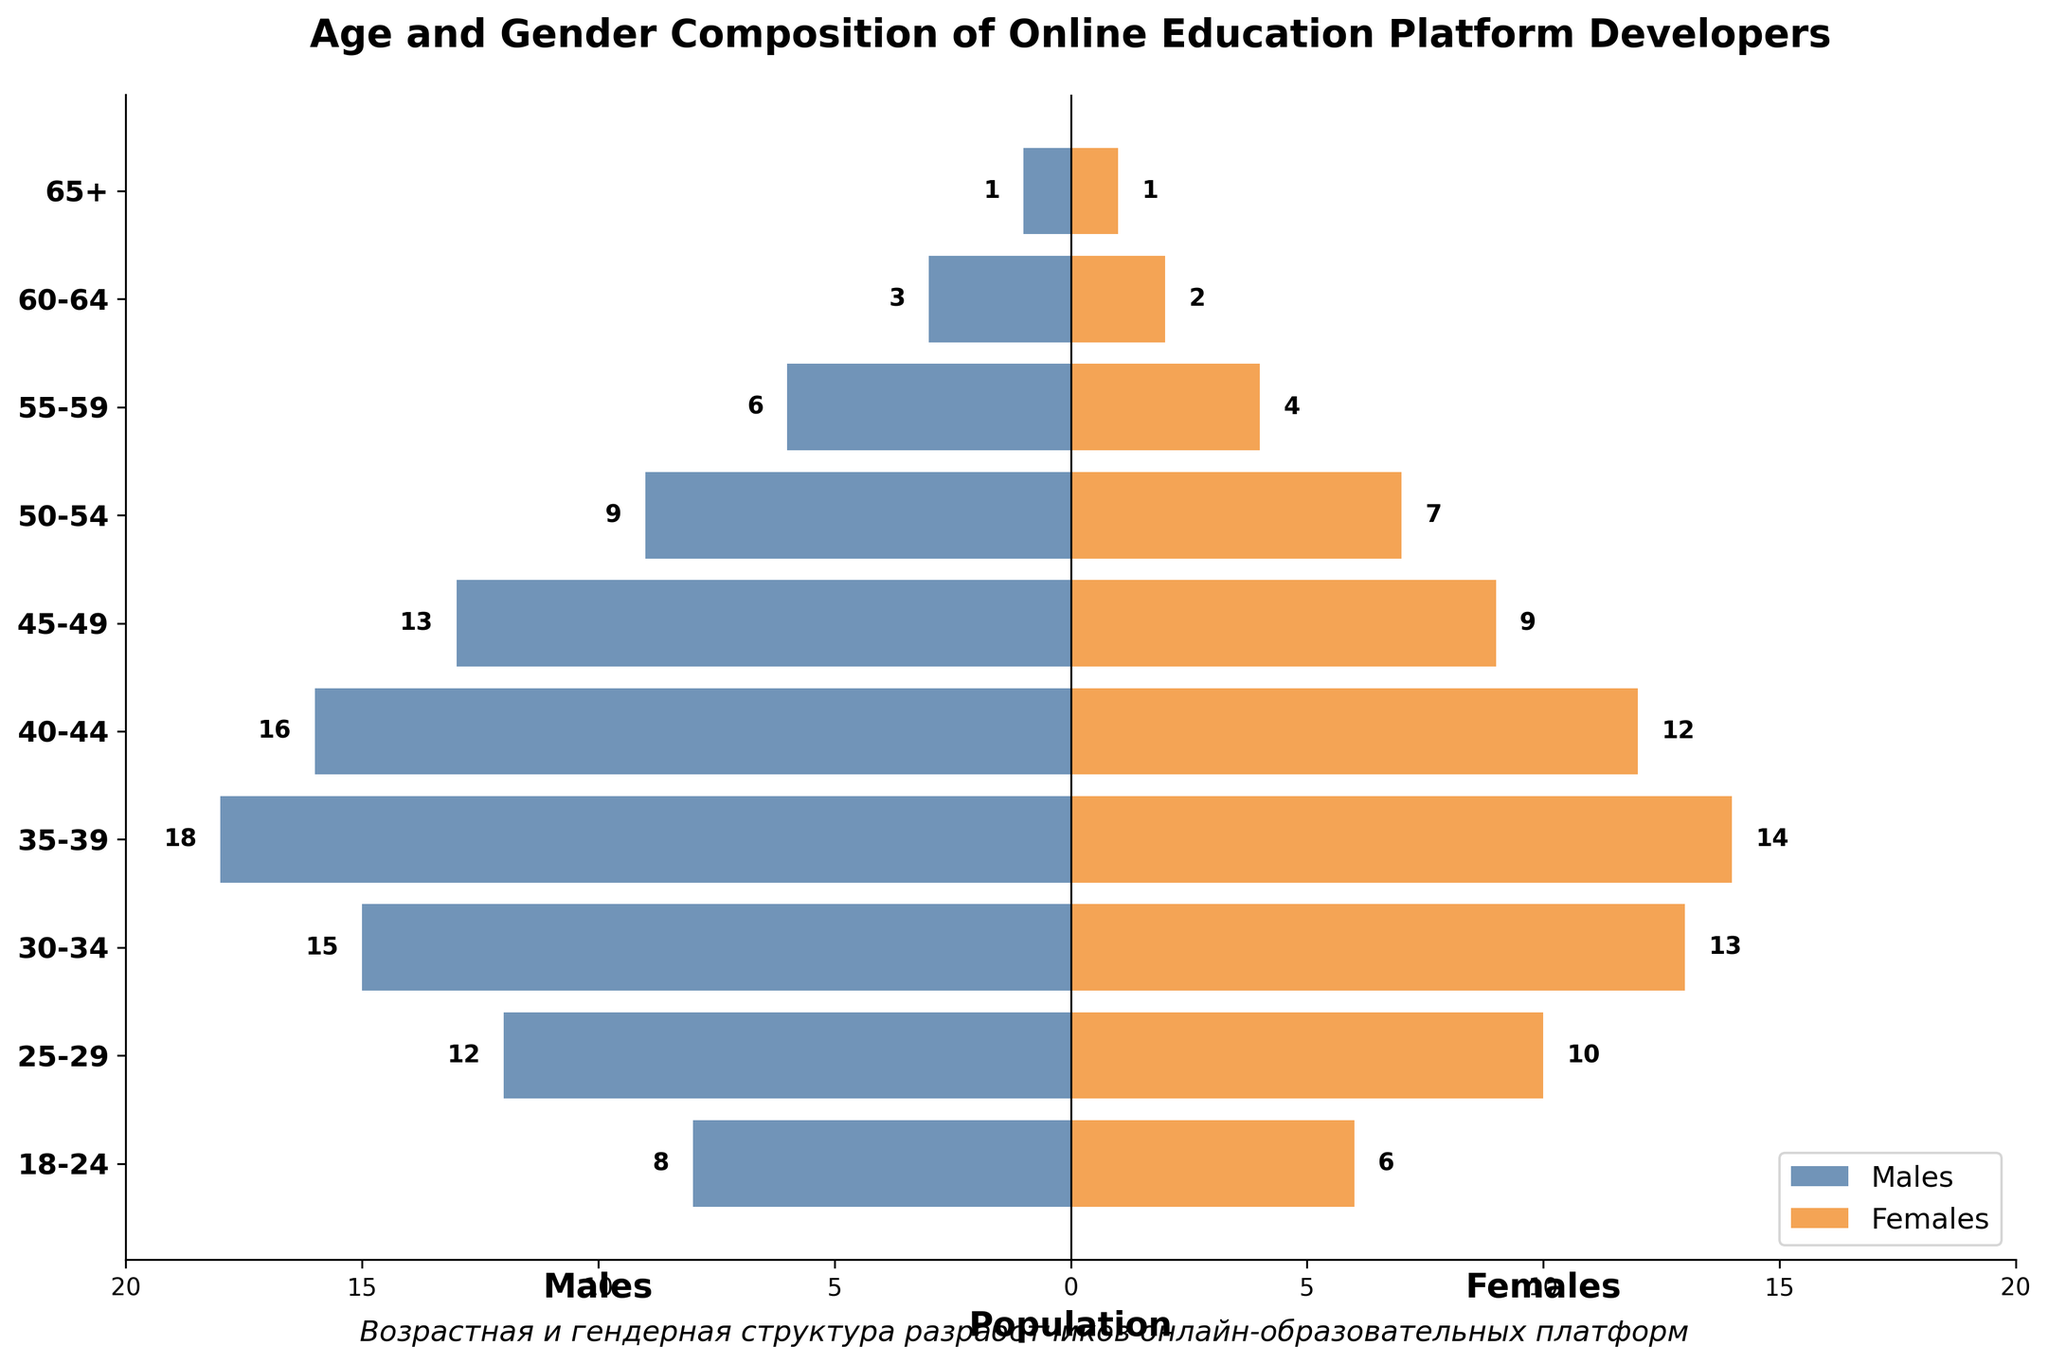How many age groups are represented in the figure? The figure shows bars labeled with different age groups. By counting these labels, you can determine the number of age groups.
Answer: 10 Which gender has more developers in the 30-34 age group? Look at the 30-34 age group bars, compare the lengths of the bars for males (negative values) and females (positive values), and see which one is longer.
Answer: Males What is the combined population of developers aged 18-24? Add the number of male developers (8) to the number of female developers (6) in the 18-24 age group.
Answer: 14 In which age group do males outnumber females the most? Examine each age group and find the one with the largest difference between the number of males and females by comparing the bar lengths.
Answer: 35-39 What is the total number of female developers shown in the figure? Sum the number of female developers across all age groups: 6 + 10 + 13 + 14 + 12 + 9 + 7 + 4 + 2 + 1 = 78.
Answer: 78 What is the average number of male developers in the age groups from 40-44 to 50-54? Add the number of male developers in these age groups (16 + 13 + 9) and divide by the number of groups (3): (16 + 13 + 9) / 3 = 12.67.
Answer: 12.67 How does the number of female developers aged 45-49 compare to those aged 55-59? Compare the lengths of the bars for females in the 45-49 (9) and 55-59 (4) age groups.
Answer: More in 45-49 In which age group is the population of developers the smallest? Identify the age group with the shortest bars for both males and females, which is the 65+ group with 1 male and 1 female.
Answer: 65+ What is the total population of developers from 60-64 and 65+ age groups combined? Add the total number of developers (males + females) from both age groups: (3 + 2) + (1 + 1) = 7.
Answer: 7 